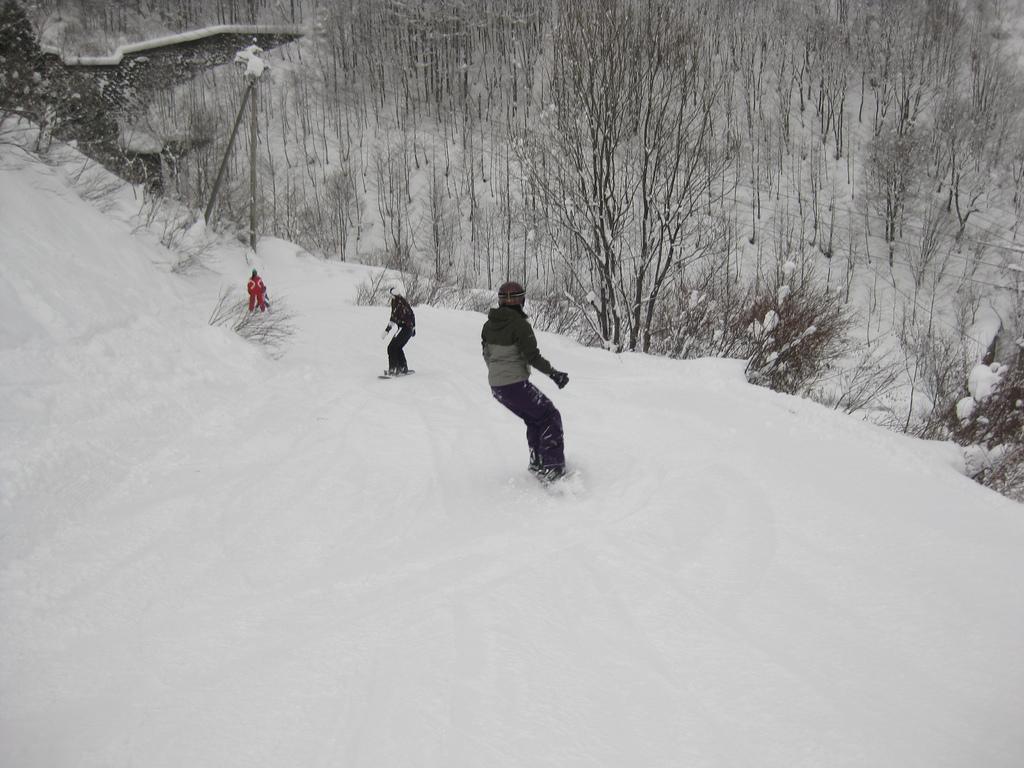Describe this image in one or two sentences. In this image in the center there are some people skating in a snow, at the bottom there is snow. And in the background there are some trees, and the trees are covered with snow and also there are some wires and poles. 